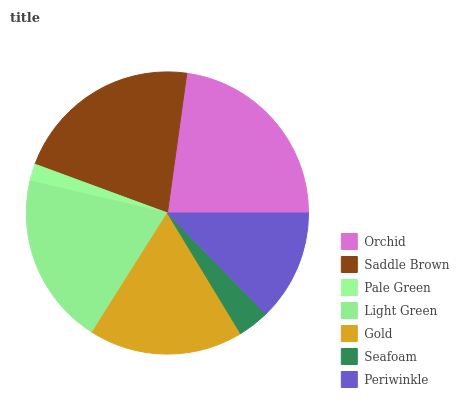Is Pale Green the minimum?
Answer yes or no. Yes. Is Orchid the maximum?
Answer yes or no. Yes. Is Saddle Brown the minimum?
Answer yes or no. No. Is Saddle Brown the maximum?
Answer yes or no. No. Is Orchid greater than Saddle Brown?
Answer yes or no. Yes. Is Saddle Brown less than Orchid?
Answer yes or no. Yes. Is Saddle Brown greater than Orchid?
Answer yes or no. No. Is Orchid less than Saddle Brown?
Answer yes or no. No. Is Gold the high median?
Answer yes or no. Yes. Is Gold the low median?
Answer yes or no. Yes. Is Light Green the high median?
Answer yes or no. No. Is Orchid the low median?
Answer yes or no. No. 